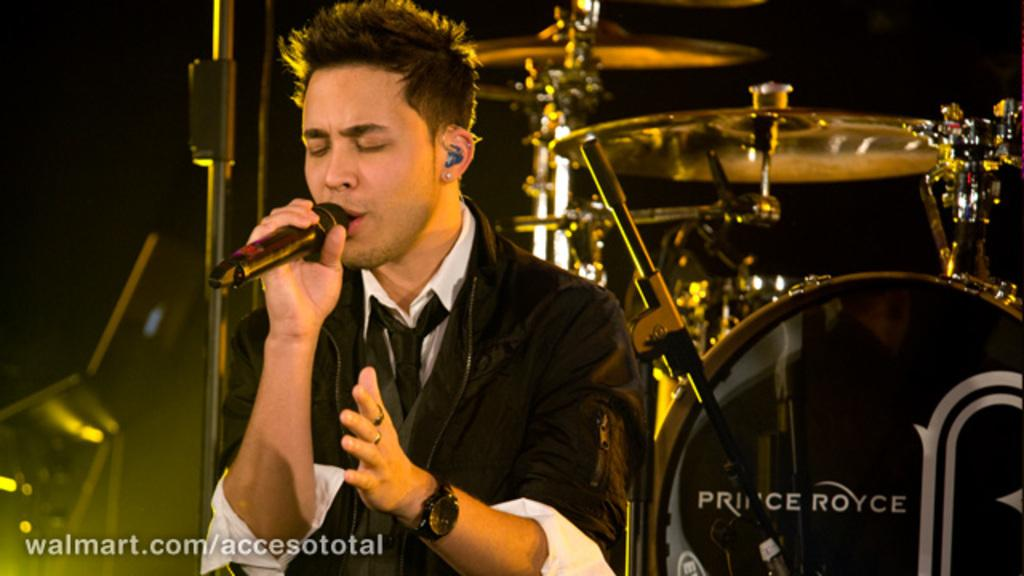Who or what is present in the image? There is a person in the image. What is the person holding in his hand? The person is holding a microphone in his hand. What can be seen in the background of the image? There is a drum set in the background of the image. What type of wrench is the person using to adjust the governor in the image? There is no wrench or governor present in the image; it features a person holding a microphone and a drum set in the background. 